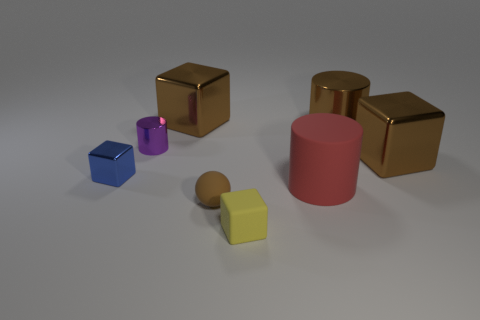Do the big metallic cylinder and the tiny rubber ball have the same color?
Provide a short and direct response. Yes. The shiny object that is right of the small purple thing and to the left of the brown ball has what shape?
Offer a very short reply. Cube. The brown thing that is the same shape as the purple metallic object is what size?
Your answer should be compact. Large. Is the number of large objects that are in front of the large metallic cylinder less than the number of large blue matte spheres?
Give a very brief answer. No. There is a brown block right of the brown metal cylinder; what is its size?
Provide a succinct answer. Large. What is the color of the other matte thing that is the same shape as the blue thing?
Provide a short and direct response. Yellow. What number of metallic things are the same color as the matte cube?
Provide a short and direct response. 0. Are there any other things that have the same shape as the brown matte object?
Provide a succinct answer. No. There is a large brown block in front of the brown cube behind the small purple shiny object; is there a small brown rubber ball on the left side of it?
Offer a terse response. Yes. How many big red cylinders have the same material as the small brown thing?
Provide a succinct answer. 1. 